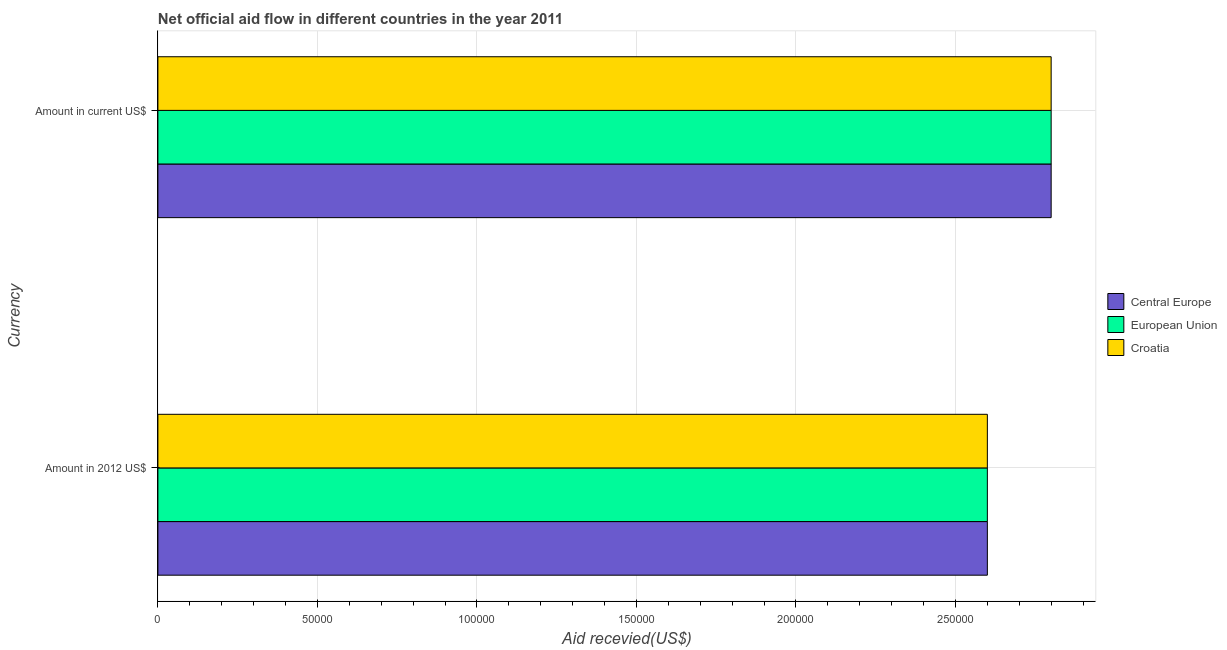How many different coloured bars are there?
Your response must be concise. 3. Are the number of bars per tick equal to the number of legend labels?
Provide a succinct answer. Yes. Are the number of bars on each tick of the Y-axis equal?
Your response must be concise. Yes. How many bars are there on the 2nd tick from the top?
Your response must be concise. 3. What is the label of the 2nd group of bars from the top?
Provide a short and direct response. Amount in 2012 US$. What is the amount of aid received(expressed in us$) in Central Europe?
Make the answer very short. 2.80e+05. Across all countries, what is the maximum amount of aid received(expressed in us$)?
Your answer should be compact. 2.80e+05. Across all countries, what is the minimum amount of aid received(expressed in us$)?
Your response must be concise. 2.80e+05. In which country was the amount of aid received(expressed in 2012 us$) maximum?
Ensure brevity in your answer.  Central Europe. In which country was the amount of aid received(expressed in us$) minimum?
Provide a short and direct response. Central Europe. What is the total amount of aid received(expressed in 2012 us$) in the graph?
Make the answer very short. 7.80e+05. What is the difference between the amount of aid received(expressed in us$) in Croatia and that in Central Europe?
Your response must be concise. 0. What is the difference between the amount of aid received(expressed in us$) in Central Europe and the amount of aid received(expressed in 2012 us$) in European Union?
Make the answer very short. 2.00e+04. What is the difference between the amount of aid received(expressed in 2012 us$) and amount of aid received(expressed in us$) in Croatia?
Offer a terse response. -2.00e+04. What is the ratio of the amount of aid received(expressed in 2012 us$) in European Union to that in Central Europe?
Offer a terse response. 1. In how many countries, is the amount of aid received(expressed in us$) greater than the average amount of aid received(expressed in us$) taken over all countries?
Offer a very short reply. 0. What does the 3rd bar from the bottom in Amount in current US$ represents?
Keep it short and to the point. Croatia. How many bars are there?
Ensure brevity in your answer.  6. Are all the bars in the graph horizontal?
Provide a short and direct response. Yes. What is the difference between two consecutive major ticks on the X-axis?
Your answer should be compact. 5.00e+04. Where does the legend appear in the graph?
Provide a short and direct response. Center right. How many legend labels are there?
Make the answer very short. 3. What is the title of the graph?
Provide a succinct answer. Net official aid flow in different countries in the year 2011. What is the label or title of the X-axis?
Your answer should be compact. Aid recevied(US$). What is the label or title of the Y-axis?
Offer a terse response. Currency. What is the Aid recevied(US$) in European Union in Amount in 2012 US$?
Your response must be concise. 2.60e+05. What is the Aid recevied(US$) of Central Europe in Amount in current US$?
Give a very brief answer. 2.80e+05. What is the Aid recevied(US$) of Croatia in Amount in current US$?
Ensure brevity in your answer.  2.80e+05. Across all Currency, what is the maximum Aid recevied(US$) in Central Europe?
Offer a very short reply. 2.80e+05. Across all Currency, what is the minimum Aid recevied(US$) of Central Europe?
Your response must be concise. 2.60e+05. Across all Currency, what is the minimum Aid recevied(US$) of Croatia?
Make the answer very short. 2.60e+05. What is the total Aid recevied(US$) of Central Europe in the graph?
Your answer should be very brief. 5.40e+05. What is the total Aid recevied(US$) of European Union in the graph?
Your answer should be compact. 5.40e+05. What is the total Aid recevied(US$) of Croatia in the graph?
Provide a short and direct response. 5.40e+05. What is the difference between the Aid recevied(US$) in Central Europe in Amount in 2012 US$ and that in Amount in current US$?
Make the answer very short. -2.00e+04. What is the difference between the Aid recevied(US$) of Croatia in Amount in 2012 US$ and that in Amount in current US$?
Provide a succinct answer. -2.00e+04. What is the difference between the Aid recevied(US$) of Central Europe in Amount in 2012 US$ and the Aid recevied(US$) of European Union in Amount in current US$?
Make the answer very short. -2.00e+04. What is the difference between the Aid recevied(US$) in European Union in Amount in 2012 US$ and the Aid recevied(US$) in Croatia in Amount in current US$?
Keep it short and to the point. -2.00e+04. What is the ratio of the Aid recevied(US$) of Central Europe in Amount in 2012 US$ to that in Amount in current US$?
Offer a terse response. 0.93. What is the ratio of the Aid recevied(US$) of European Union in Amount in 2012 US$ to that in Amount in current US$?
Your answer should be compact. 0.93. What is the difference between the highest and the second highest Aid recevied(US$) of European Union?
Offer a terse response. 2.00e+04. 